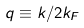<formula> <loc_0><loc_0><loc_500><loc_500>q \equiv k / 2 k _ { F }</formula> 